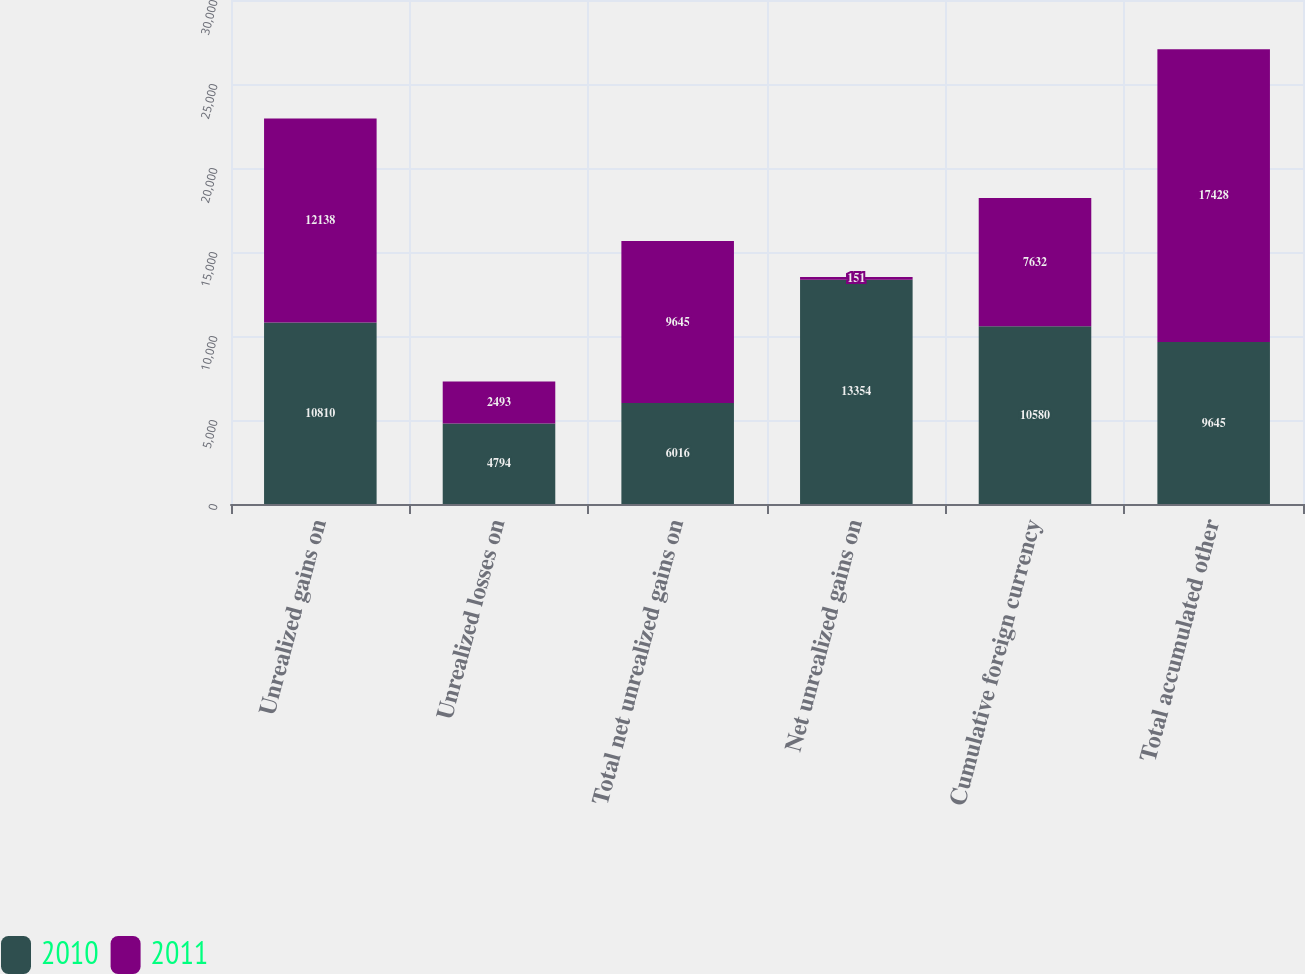Convert chart. <chart><loc_0><loc_0><loc_500><loc_500><stacked_bar_chart><ecel><fcel>Unrealized gains on<fcel>Unrealized losses on<fcel>Total net unrealized gains on<fcel>Net unrealized gains on<fcel>Cumulative foreign currency<fcel>Total accumulated other<nl><fcel>2010<fcel>10810<fcel>4794<fcel>6016<fcel>13354<fcel>10580<fcel>9645<nl><fcel>2011<fcel>12138<fcel>2493<fcel>9645<fcel>151<fcel>7632<fcel>17428<nl></chart> 